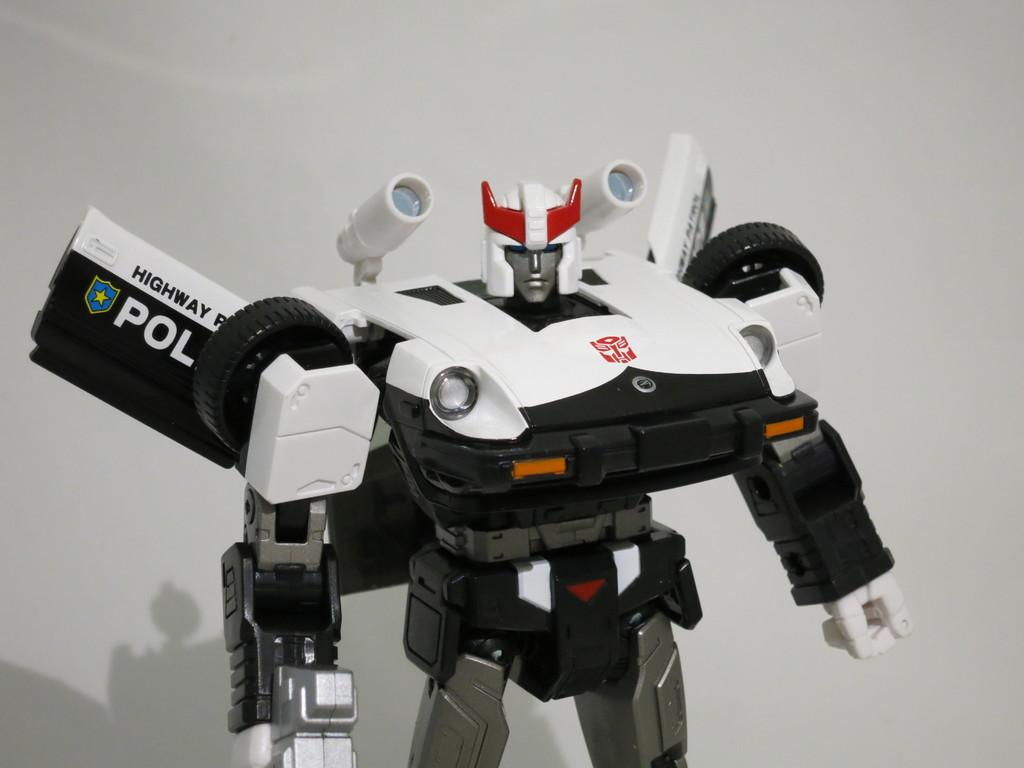<image>
Offer a succinct explanation of the picture presented. A black and white transformer toy says Highway Patrol Police. 